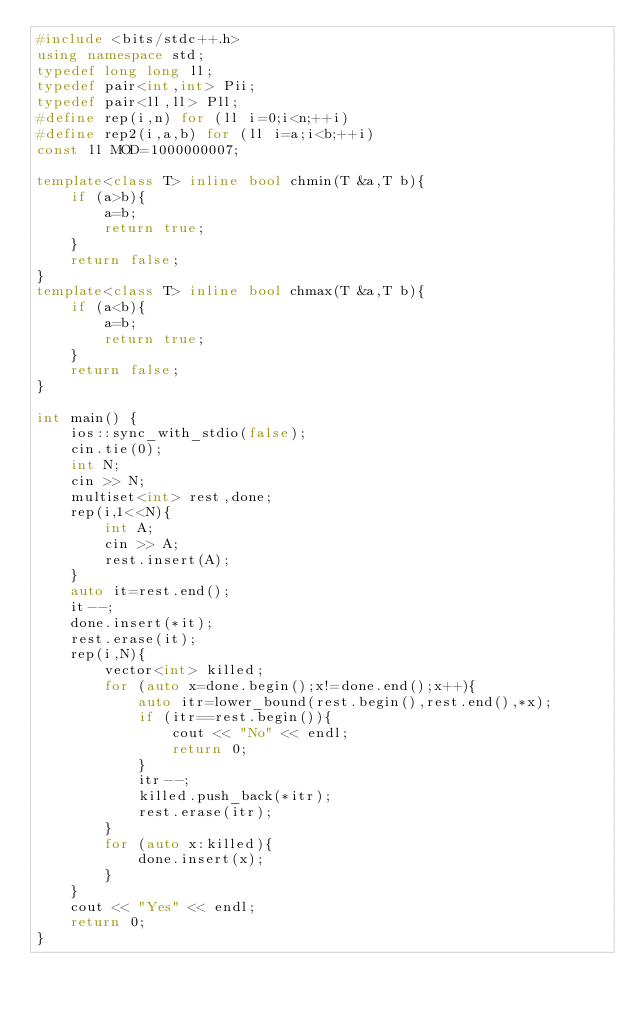<code> <loc_0><loc_0><loc_500><loc_500><_C++_>#include <bits/stdc++.h>
using namespace std;
typedef long long ll;
typedef pair<int,int> Pii;
typedef pair<ll,ll> Pll;
#define rep(i,n) for (ll i=0;i<n;++i)
#define rep2(i,a,b) for (ll i=a;i<b;++i)
const ll MOD=1000000007;

template<class T> inline bool chmin(T &a,T b){
    if (a>b){
        a=b;
        return true;
    }
    return false;
}
template<class T> inline bool chmax(T &a,T b){
    if (a<b){
        a=b;
        return true;
    }
    return false;
}

int main() {
    ios::sync_with_stdio(false);
    cin.tie(0);
    int N;
    cin >> N;
    multiset<int> rest,done;
    rep(i,1<<N){
        int A;
        cin >> A;
        rest.insert(A);
    }
    auto it=rest.end();
    it--;
    done.insert(*it);
    rest.erase(it);
    rep(i,N){
        vector<int> killed;
        for (auto x=done.begin();x!=done.end();x++){
            auto itr=lower_bound(rest.begin(),rest.end(),*x);
            if (itr==rest.begin()){
                cout << "No" << endl;
                return 0;
            }
            itr--;
            killed.push_back(*itr);
            rest.erase(itr);
        }
        for (auto x:killed){
            done.insert(x);
        }
    }
    cout << "Yes" << endl;
    return 0;
}</code> 